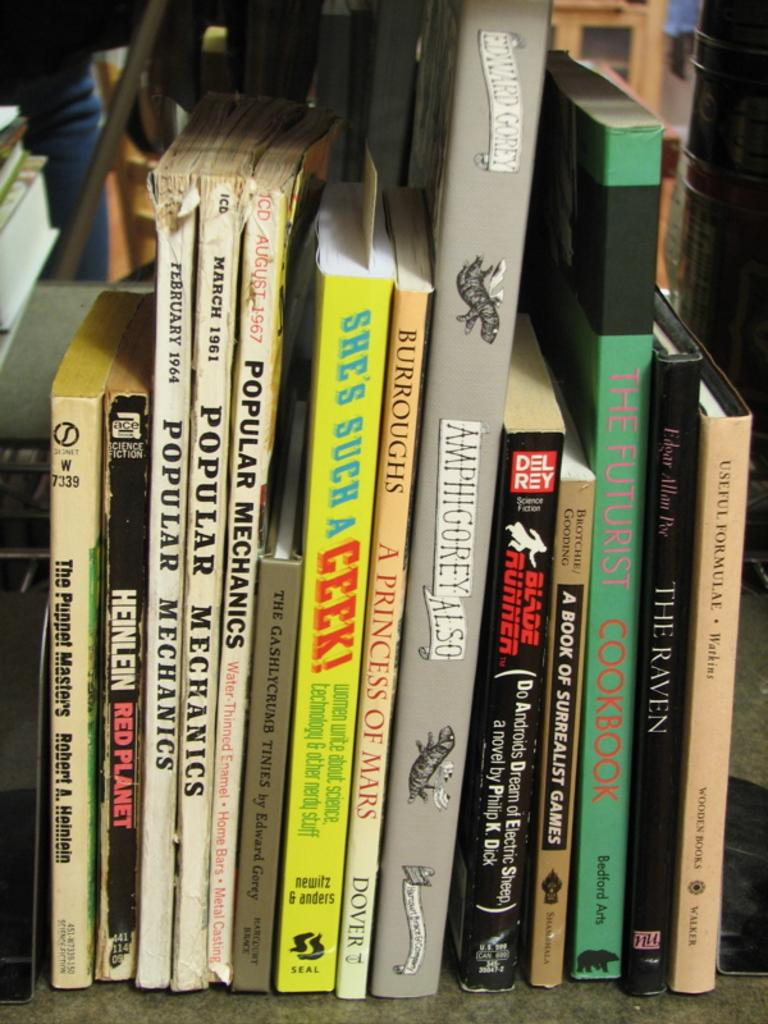What is the main subject of the image? The main subject of the image is books arranged in rows. Can you describe the arrangement of the books? The books are arranged in rows, which suggests they might be part of a bookshelf or library. Is there anyone present in the image? Yes, there is a person standing on the floor in the image. What type of fruit can be seen on the bookshelf in the image? There is no fruit present on the bookshelf in the image; it only contains books arranged in rows. 